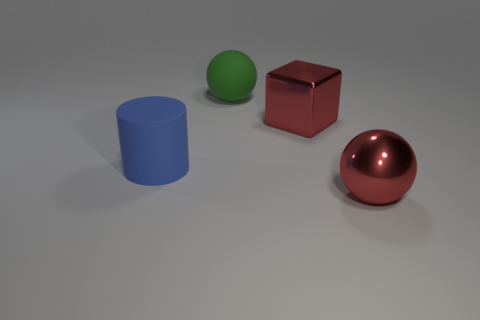How many big things are to the left of the red metallic thing that is in front of the big red block? To the left of the red metallic sphere, there are two objects: a large blue cylinder and a green sphere. These are considered the 'big things' relative to the red metallic sphere's position in front of the sizable red block. 